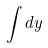Convert formula to latex. <formula><loc_0><loc_0><loc_500><loc_500>\int d y</formula> 